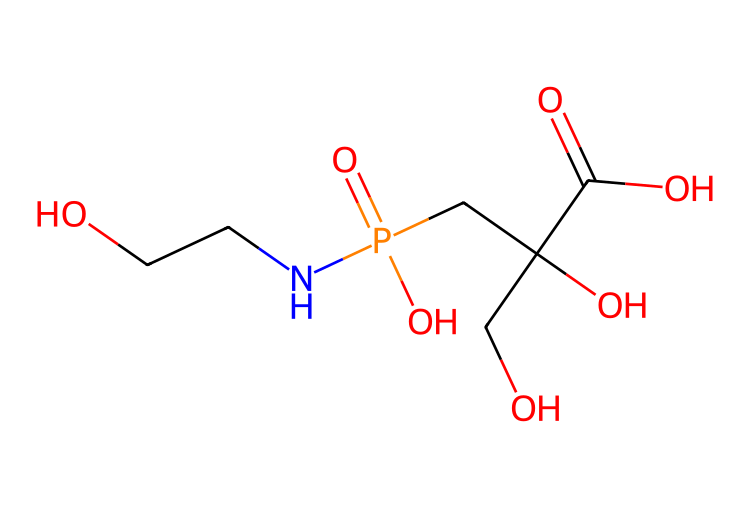How many carbon atoms are in glyphosate? To determine the number of carbon atoms in glyphosate, look at the SMILES representation and identify the 'C' symbols. In the given SMILES, there are 5 instances of 'C', indicating there are 5 carbon atoms.
Answer: 5 What functional groups are present in glyphosate? By analyzing the SMILES representation, we can identify different functional groups: the presence of -OH groups (hydroxyl), -COOH (carboxylic acid), and -PO4 (phosphate group). Therefore, glyphosate contains hydroxyl, carboxylic acid, and phosphate functional groups.
Answer: hydroxyl, carboxylic acid, phosphate What is the overall charge of glyphosate at physiological pH? Glyphosate contains a phosphate group, which can carry a negative charge in physiological conditions. The amino group (NH) can be protonated, adding one positive charge. Overall, with one negative and one positive charge, glyphosate is neutral.
Answer: neutral How many nitrogen atoms are in glyphosate? In the SMILES, the 'N' character represents nitrogen. There is one 'N' in the representation, indicating there is one nitrogen atom present in glyphosate.
Answer: 1 What type of herbicide is glyphosate classified as? Glyphosate is classified as a non-selective herbicide, meaning it can kill any plant it comes into contact with, as it inhibits a specific enzyme pathway found in plants and some microorganisms.
Answer: non-selective Which part of glyphosate inhibits the shikimic acid pathway? The glyphosate molecule's ability to inhibit the shikimic acid pathway is due to the phosphonomethyl group (-PO2H2), which is present in its structure. This group is crucial for glyphosate's function as an herbicide.
Answer: phosphonomethyl group 